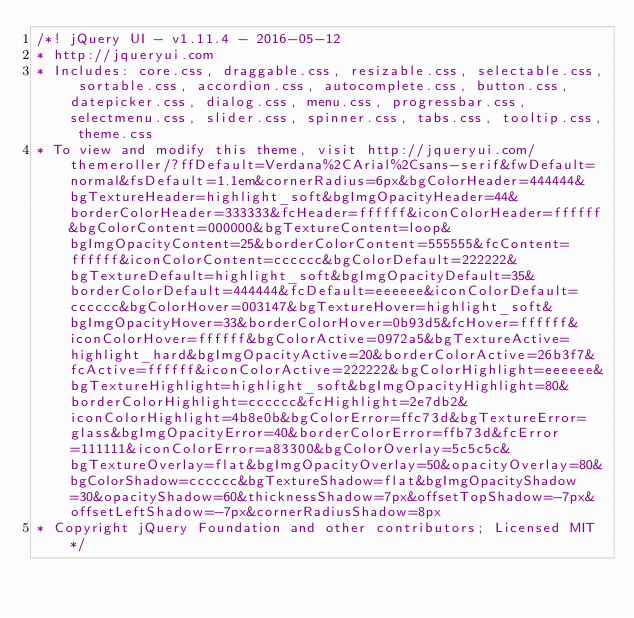<code> <loc_0><loc_0><loc_500><loc_500><_CSS_>/*! jQuery UI - v1.11.4 - 2016-05-12
* http://jqueryui.com
* Includes: core.css, draggable.css, resizable.css, selectable.css, sortable.css, accordion.css, autocomplete.css, button.css, datepicker.css, dialog.css, menu.css, progressbar.css, selectmenu.css, slider.css, spinner.css, tabs.css, tooltip.css, theme.css
* To view and modify this theme, visit http://jqueryui.com/themeroller/?ffDefault=Verdana%2CArial%2Csans-serif&fwDefault=normal&fsDefault=1.1em&cornerRadius=6px&bgColorHeader=444444&bgTextureHeader=highlight_soft&bgImgOpacityHeader=44&borderColorHeader=333333&fcHeader=ffffff&iconColorHeader=ffffff&bgColorContent=000000&bgTextureContent=loop&bgImgOpacityContent=25&borderColorContent=555555&fcContent=ffffff&iconColorContent=cccccc&bgColorDefault=222222&bgTextureDefault=highlight_soft&bgImgOpacityDefault=35&borderColorDefault=444444&fcDefault=eeeeee&iconColorDefault=cccccc&bgColorHover=003147&bgTextureHover=highlight_soft&bgImgOpacityHover=33&borderColorHover=0b93d5&fcHover=ffffff&iconColorHover=ffffff&bgColorActive=0972a5&bgTextureActive=highlight_hard&bgImgOpacityActive=20&borderColorActive=26b3f7&fcActive=ffffff&iconColorActive=222222&bgColorHighlight=eeeeee&bgTextureHighlight=highlight_soft&bgImgOpacityHighlight=80&borderColorHighlight=cccccc&fcHighlight=2e7db2&iconColorHighlight=4b8e0b&bgColorError=ffc73d&bgTextureError=glass&bgImgOpacityError=40&borderColorError=ffb73d&fcError=111111&iconColorError=a83300&bgColorOverlay=5c5c5c&bgTextureOverlay=flat&bgImgOpacityOverlay=50&opacityOverlay=80&bgColorShadow=cccccc&bgTextureShadow=flat&bgImgOpacityShadow=30&opacityShadow=60&thicknessShadow=7px&offsetTopShadow=-7px&offsetLeftShadow=-7px&cornerRadiusShadow=8px
* Copyright jQuery Foundation and other contributors; Licensed MIT */
</code> 